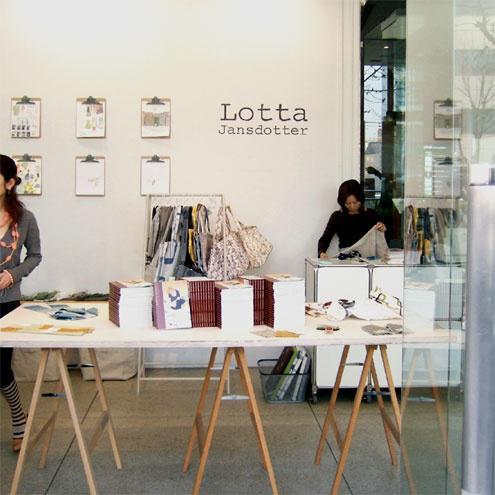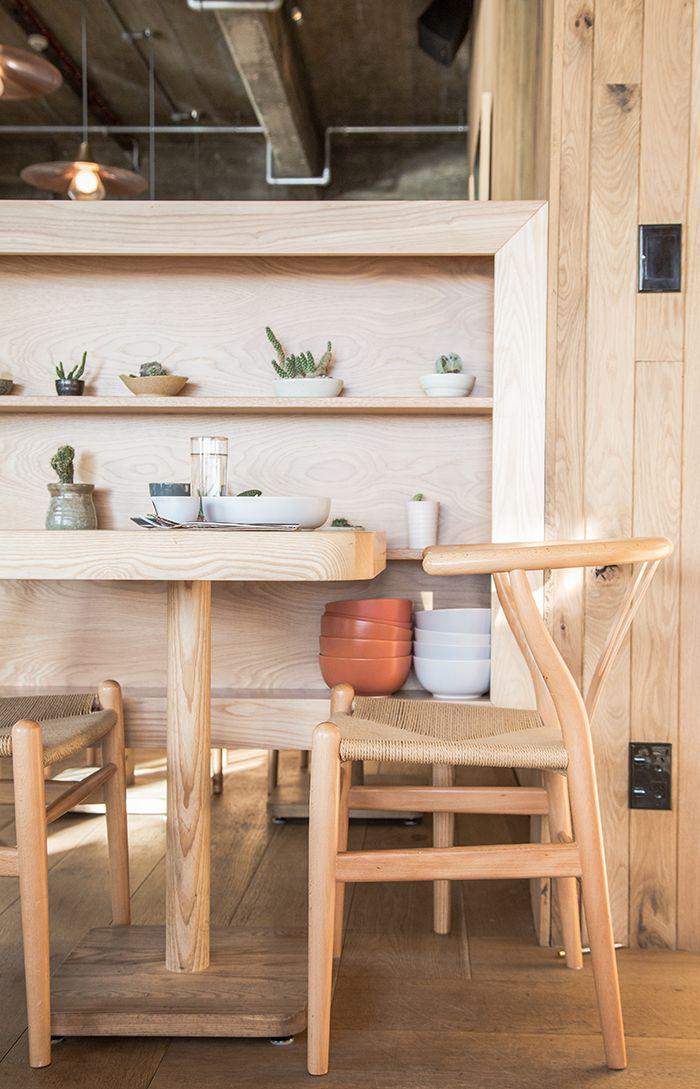The first image is the image on the left, the second image is the image on the right. Examine the images to the left and right. Is the description "There are chairs in both images." accurate? Answer yes or no. No. The first image is the image on the left, the second image is the image on the right. Evaluate the accuracy of this statement regarding the images: "Each image shows a seating area with lights suspended over it, and one of the images features black chairs in front of small square tables flush with a low wall.". Is it true? Answer yes or no. No. 